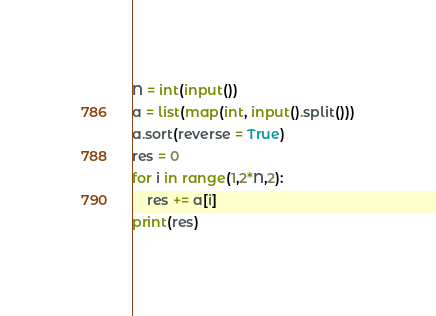Convert code to text. <code><loc_0><loc_0><loc_500><loc_500><_Python_>N = int(input())
a = list(map(int, input().split()))
a.sort(reverse = True)
res = 0
for i in range(1,2*N,2):
    res += a[i]
print(res)</code> 